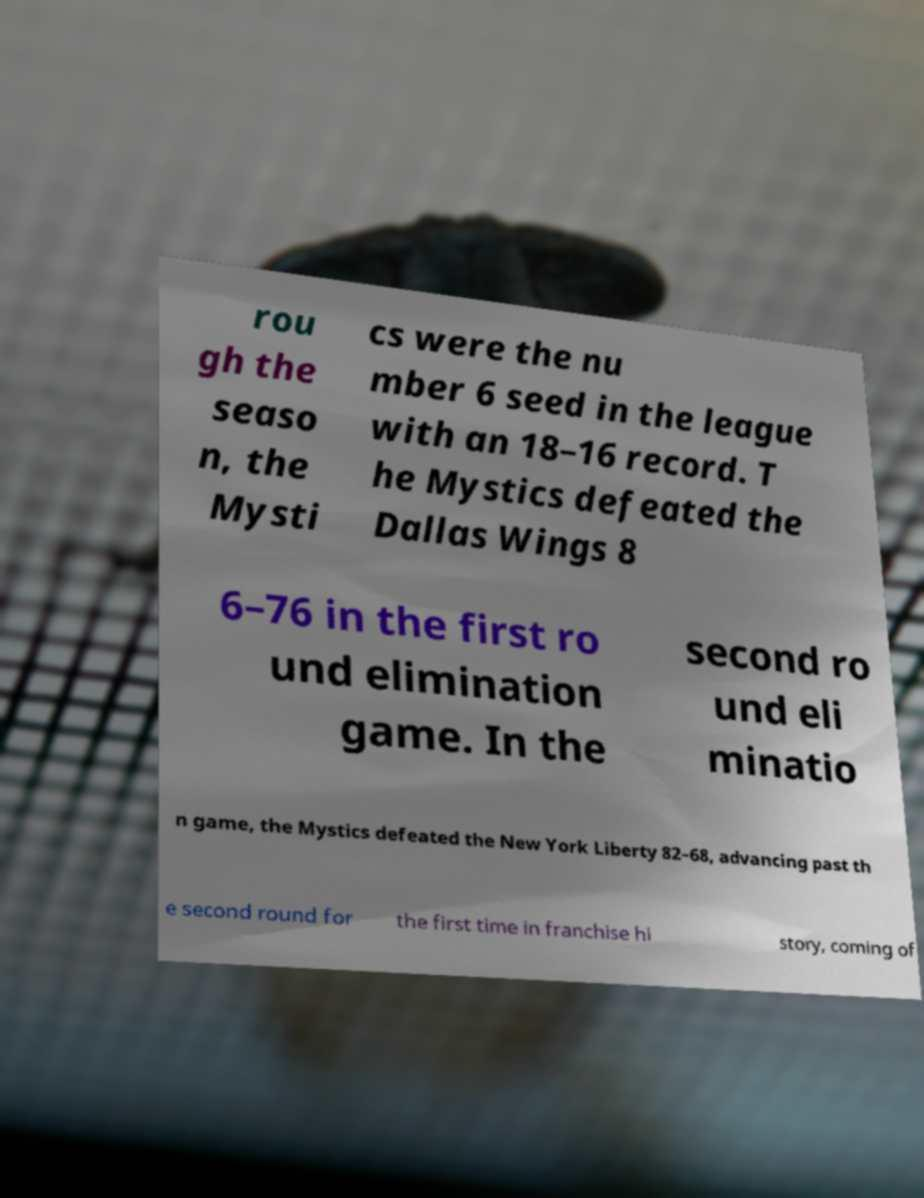Please read and relay the text visible in this image. What does it say? rou gh the seaso n, the Mysti cs were the nu mber 6 seed in the league with an 18–16 record. T he Mystics defeated the Dallas Wings 8 6–76 in the first ro und elimination game. In the second ro und eli minatio n game, the Mystics defeated the New York Liberty 82–68, advancing past th e second round for the first time in franchise hi story, coming of 